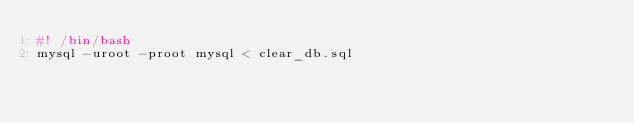<code> <loc_0><loc_0><loc_500><loc_500><_Bash_>#! /bin/bash
mysql -uroot -proot mysql < clear_db.sql</code> 